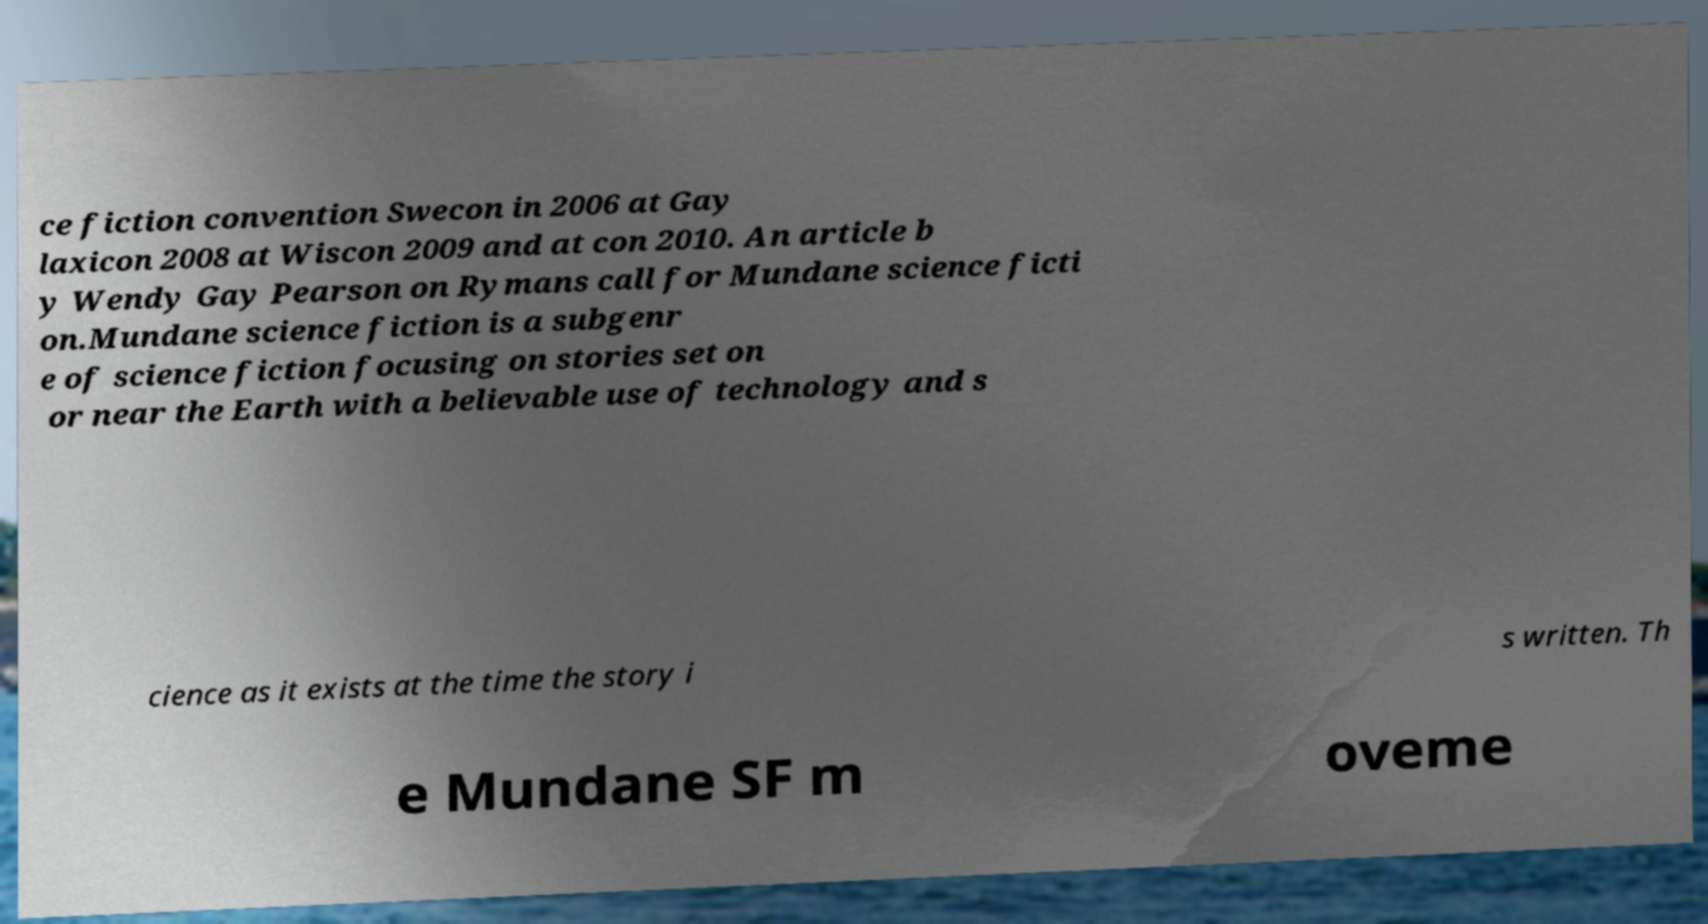What messages or text are displayed in this image? I need them in a readable, typed format. ce fiction convention Swecon in 2006 at Gay laxicon 2008 at Wiscon 2009 and at con 2010. An article b y Wendy Gay Pearson on Rymans call for Mundane science ficti on.Mundane science fiction is a subgenr e of science fiction focusing on stories set on or near the Earth with a believable use of technology and s cience as it exists at the time the story i s written. Th e Mundane SF m oveme 